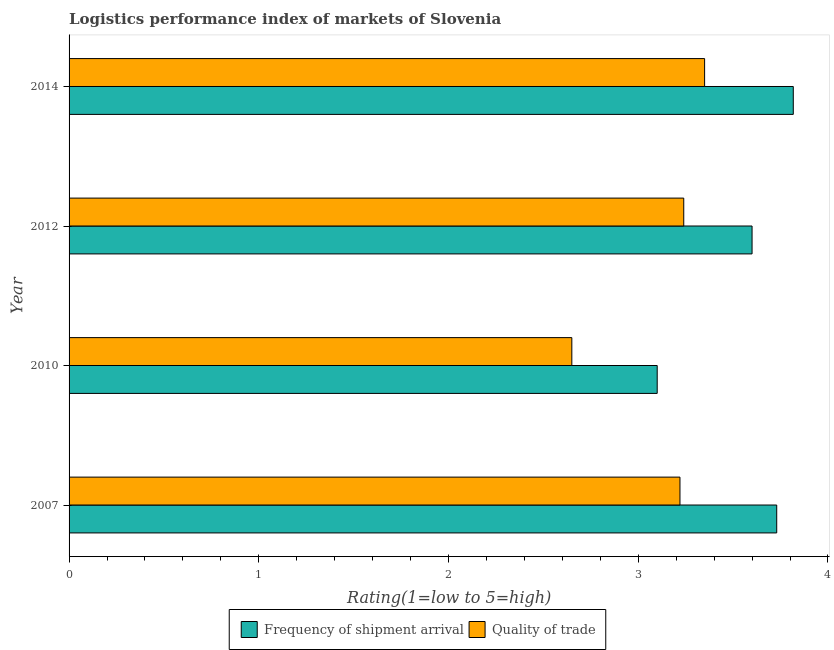How many different coloured bars are there?
Ensure brevity in your answer.  2. How many groups of bars are there?
Make the answer very short. 4. Are the number of bars per tick equal to the number of legend labels?
Give a very brief answer. Yes. Are the number of bars on each tick of the Y-axis equal?
Give a very brief answer. Yes. How many bars are there on the 1st tick from the top?
Your answer should be very brief. 2. How many bars are there on the 1st tick from the bottom?
Your answer should be very brief. 2. In how many cases, is the number of bars for a given year not equal to the number of legend labels?
Offer a very short reply. 0. What is the lpi quality of trade in 2010?
Your answer should be compact. 2.65. Across all years, what is the maximum lpi quality of trade?
Provide a short and direct response. 3.35. Across all years, what is the minimum lpi quality of trade?
Provide a short and direct response. 2.65. In which year was the lpi of frequency of shipment arrival minimum?
Provide a succinct answer. 2010. What is the total lpi quality of trade in the graph?
Provide a short and direct response. 12.46. What is the difference between the lpi of frequency of shipment arrival in 2007 and that in 2012?
Your answer should be very brief. 0.13. What is the difference between the lpi of frequency of shipment arrival in 2012 and the lpi quality of trade in 2007?
Keep it short and to the point. 0.38. What is the average lpi of frequency of shipment arrival per year?
Your response must be concise. 3.56. In the year 2012, what is the difference between the lpi of frequency of shipment arrival and lpi quality of trade?
Offer a very short reply. 0.36. What is the ratio of the lpi of frequency of shipment arrival in 2007 to that in 2010?
Make the answer very short. 1.2. Is the lpi quality of trade in 2012 less than that in 2014?
Offer a very short reply. Yes. What is the difference between the highest and the second highest lpi quality of trade?
Provide a succinct answer. 0.11. What is the difference between the highest and the lowest lpi of frequency of shipment arrival?
Provide a short and direct response. 0.72. In how many years, is the lpi quality of trade greater than the average lpi quality of trade taken over all years?
Make the answer very short. 3. Is the sum of the lpi quality of trade in 2007 and 2014 greater than the maximum lpi of frequency of shipment arrival across all years?
Offer a terse response. Yes. What does the 2nd bar from the top in 2010 represents?
Provide a short and direct response. Frequency of shipment arrival. What does the 2nd bar from the bottom in 2010 represents?
Provide a short and direct response. Quality of trade. How many bars are there?
Your response must be concise. 8. Are all the bars in the graph horizontal?
Your response must be concise. Yes. What is the difference between two consecutive major ticks on the X-axis?
Make the answer very short. 1. Are the values on the major ticks of X-axis written in scientific E-notation?
Offer a terse response. No. Does the graph contain any zero values?
Your response must be concise. No. What is the title of the graph?
Offer a very short reply. Logistics performance index of markets of Slovenia. Does "Food and tobacco" appear as one of the legend labels in the graph?
Provide a short and direct response. No. What is the label or title of the X-axis?
Your response must be concise. Rating(1=low to 5=high). What is the label or title of the Y-axis?
Offer a terse response. Year. What is the Rating(1=low to 5=high) in Frequency of shipment arrival in 2007?
Offer a terse response. 3.73. What is the Rating(1=low to 5=high) in Quality of trade in 2007?
Your answer should be very brief. 3.22. What is the Rating(1=low to 5=high) of Frequency of shipment arrival in 2010?
Provide a short and direct response. 3.1. What is the Rating(1=low to 5=high) in Quality of trade in 2010?
Ensure brevity in your answer.  2.65. What is the Rating(1=low to 5=high) of Frequency of shipment arrival in 2012?
Give a very brief answer. 3.6. What is the Rating(1=low to 5=high) in Quality of trade in 2012?
Give a very brief answer. 3.24. What is the Rating(1=low to 5=high) of Frequency of shipment arrival in 2014?
Provide a short and direct response. 3.82. What is the Rating(1=low to 5=high) in Quality of trade in 2014?
Offer a terse response. 3.35. Across all years, what is the maximum Rating(1=low to 5=high) in Frequency of shipment arrival?
Your answer should be very brief. 3.82. Across all years, what is the maximum Rating(1=low to 5=high) of Quality of trade?
Your answer should be compact. 3.35. Across all years, what is the minimum Rating(1=low to 5=high) of Frequency of shipment arrival?
Keep it short and to the point. 3.1. Across all years, what is the minimum Rating(1=low to 5=high) of Quality of trade?
Give a very brief answer. 2.65. What is the total Rating(1=low to 5=high) of Frequency of shipment arrival in the graph?
Your response must be concise. 14.25. What is the total Rating(1=low to 5=high) in Quality of trade in the graph?
Make the answer very short. 12.46. What is the difference between the Rating(1=low to 5=high) of Frequency of shipment arrival in 2007 and that in 2010?
Give a very brief answer. 0.63. What is the difference between the Rating(1=low to 5=high) in Quality of trade in 2007 and that in 2010?
Offer a terse response. 0.57. What is the difference between the Rating(1=low to 5=high) of Frequency of shipment arrival in 2007 and that in 2012?
Offer a terse response. 0.13. What is the difference between the Rating(1=low to 5=high) of Quality of trade in 2007 and that in 2012?
Make the answer very short. -0.02. What is the difference between the Rating(1=low to 5=high) of Frequency of shipment arrival in 2007 and that in 2014?
Give a very brief answer. -0.09. What is the difference between the Rating(1=low to 5=high) in Quality of trade in 2007 and that in 2014?
Provide a succinct answer. -0.13. What is the difference between the Rating(1=low to 5=high) of Quality of trade in 2010 and that in 2012?
Your answer should be compact. -0.59. What is the difference between the Rating(1=low to 5=high) in Frequency of shipment arrival in 2010 and that in 2014?
Give a very brief answer. -0.72. What is the difference between the Rating(1=low to 5=high) in Quality of trade in 2010 and that in 2014?
Offer a very short reply. -0.7. What is the difference between the Rating(1=low to 5=high) in Frequency of shipment arrival in 2012 and that in 2014?
Your answer should be compact. -0.22. What is the difference between the Rating(1=low to 5=high) of Quality of trade in 2012 and that in 2014?
Keep it short and to the point. -0.11. What is the difference between the Rating(1=low to 5=high) of Frequency of shipment arrival in 2007 and the Rating(1=low to 5=high) of Quality of trade in 2010?
Keep it short and to the point. 1.08. What is the difference between the Rating(1=low to 5=high) of Frequency of shipment arrival in 2007 and the Rating(1=low to 5=high) of Quality of trade in 2012?
Keep it short and to the point. 0.49. What is the difference between the Rating(1=low to 5=high) of Frequency of shipment arrival in 2007 and the Rating(1=low to 5=high) of Quality of trade in 2014?
Ensure brevity in your answer.  0.38. What is the difference between the Rating(1=low to 5=high) in Frequency of shipment arrival in 2010 and the Rating(1=low to 5=high) in Quality of trade in 2012?
Provide a succinct answer. -0.14. What is the difference between the Rating(1=low to 5=high) in Frequency of shipment arrival in 2010 and the Rating(1=low to 5=high) in Quality of trade in 2014?
Provide a short and direct response. -0.25. What is the difference between the Rating(1=low to 5=high) of Frequency of shipment arrival in 2012 and the Rating(1=low to 5=high) of Quality of trade in 2014?
Your answer should be compact. 0.25. What is the average Rating(1=low to 5=high) in Frequency of shipment arrival per year?
Give a very brief answer. 3.56. What is the average Rating(1=low to 5=high) in Quality of trade per year?
Offer a terse response. 3.12. In the year 2007, what is the difference between the Rating(1=low to 5=high) in Frequency of shipment arrival and Rating(1=low to 5=high) in Quality of trade?
Your answer should be compact. 0.51. In the year 2010, what is the difference between the Rating(1=low to 5=high) of Frequency of shipment arrival and Rating(1=low to 5=high) of Quality of trade?
Keep it short and to the point. 0.45. In the year 2012, what is the difference between the Rating(1=low to 5=high) of Frequency of shipment arrival and Rating(1=low to 5=high) of Quality of trade?
Make the answer very short. 0.36. In the year 2014, what is the difference between the Rating(1=low to 5=high) in Frequency of shipment arrival and Rating(1=low to 5=high) in Quality of trade?
Your response must be concise. 0.47. What is the ratio of the Rating(1=low to 5=high) of Frequency of shipment arrival in 2007 to that in 2010?
Keep it short and to the point. 1.2. What is the ratio of the Rating(1=low to 5=high) of Quality of trade in 2007 to that in 2010?
Your answer should be compact. 1.22. What is the ratio of the Rating(1=low to 5=high) in Frequency of shipment arrival in 2007 to that in 2012?
Offer a terse response. 1.04. What is the ratio of the Rating(1=low to 5=high) of Frequency of shipment arrival in 2007 to that in 2014?
Offer a very short reply. 0.98. What is the ratio of the Rating(1=low to 5=high) of Quality of trade in 2007 to that in 2014?
Keep it short and to the point. 0.96. What is the ratio of the Rating(1=low to 5=high) of Frequency of shipment arrival in 2010 to that in 2012?
Your response must be concise. 0.86. What is the ratio of the Rating(1=low to 5=high) of Quality of trade in 2010 to that in 2012?
Your response must be concise. 0.82. What is the ratio of the Rating(1=low to 5=high) in Frequency of shipment arrival in 2010 to that in 2014?
Your answer should be very brief. 0.81. What is the ratio of the Rating(1=low to 5=high) of Quality of trade in 2010 to that in 2014?
Your answer should be very brief. 0.79. What is the ratio of the Rating(1=low to 5=high) of Frequency of shipment arrival in 2012 to that in 2014?
Your answer should be compact. 0.94. What is the ratio of the Rating(1=low to 5=high) of Quality of trade in 2012 to that in 2014?
Your response must be concise. 0.97. What is the difference between the highest and the second highest Rating(1=low to 5=high) in Frequency of shipment arrival?
Keep it short and to the point. 0.09. What is the difference between the highest and the second highest Rating(1=low to 5=high) of Quality of trade?
Ensure brevity in your answer.  0.11. What is the difference between the highest and the lowest Rating(1=low to 5=high) of Frequency of shipment arrival?
Ensure brevity in your answer.  0.72. What is the difference between the highest and the lowest Rating(1=low to 5=high) in Quality of trade?
Keep it short and to the point. 0.7. 